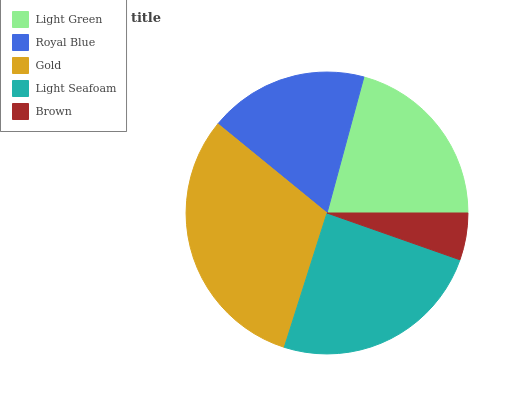Is Brown the minimum?
Answer yes or no. Yes. Is Gold the maximum?
Answer yes or no. Yes. Is Royal Blue the minimum?
Answer yes or no. No. Is Royal Blue the maximum?
Answer yes or no. No. Is Light Green greater than Royal Blue?
Answer yes or no. Yes. Is Royal Blue less than Light Green?
Answer yes or no. Yes. Is Royal Blue greater than Light Green?
Answer yes or no. No. Is Light Green less than Royal Blue?
Answer yes or no. No. Is Light Green the high median?
Answer yes or no. Yes. Is Light Green the low median?
Answer yes or no. Yes. Is Brown the high median?
Answer yes or no. No. Is Royal Blue the low median?
Answer yes or no. No. 